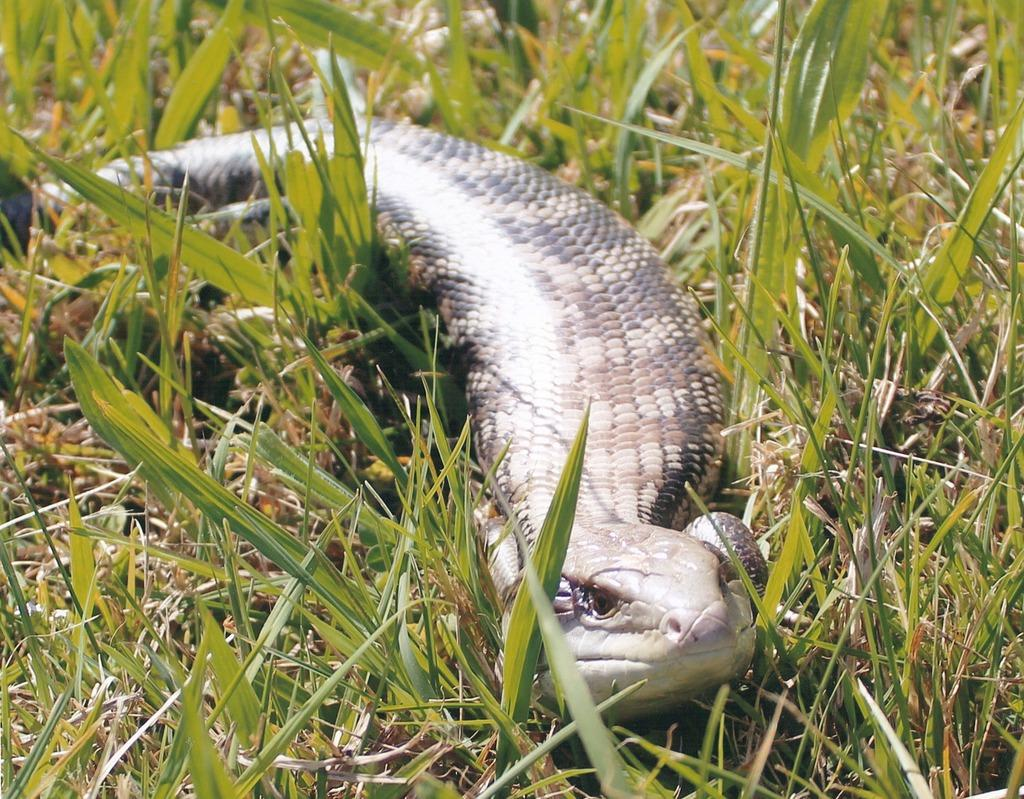What animal is present in the image? There is a snake in the image. What type of terrain is the snake on? The snake is on grass. Where is the nearest hydrant to the snake in the image? There is no hydrant present in the image, as it features a snake on grass. What type of government is depicted in the image? There is no government depicted in the image, as it features a snake on grass. 